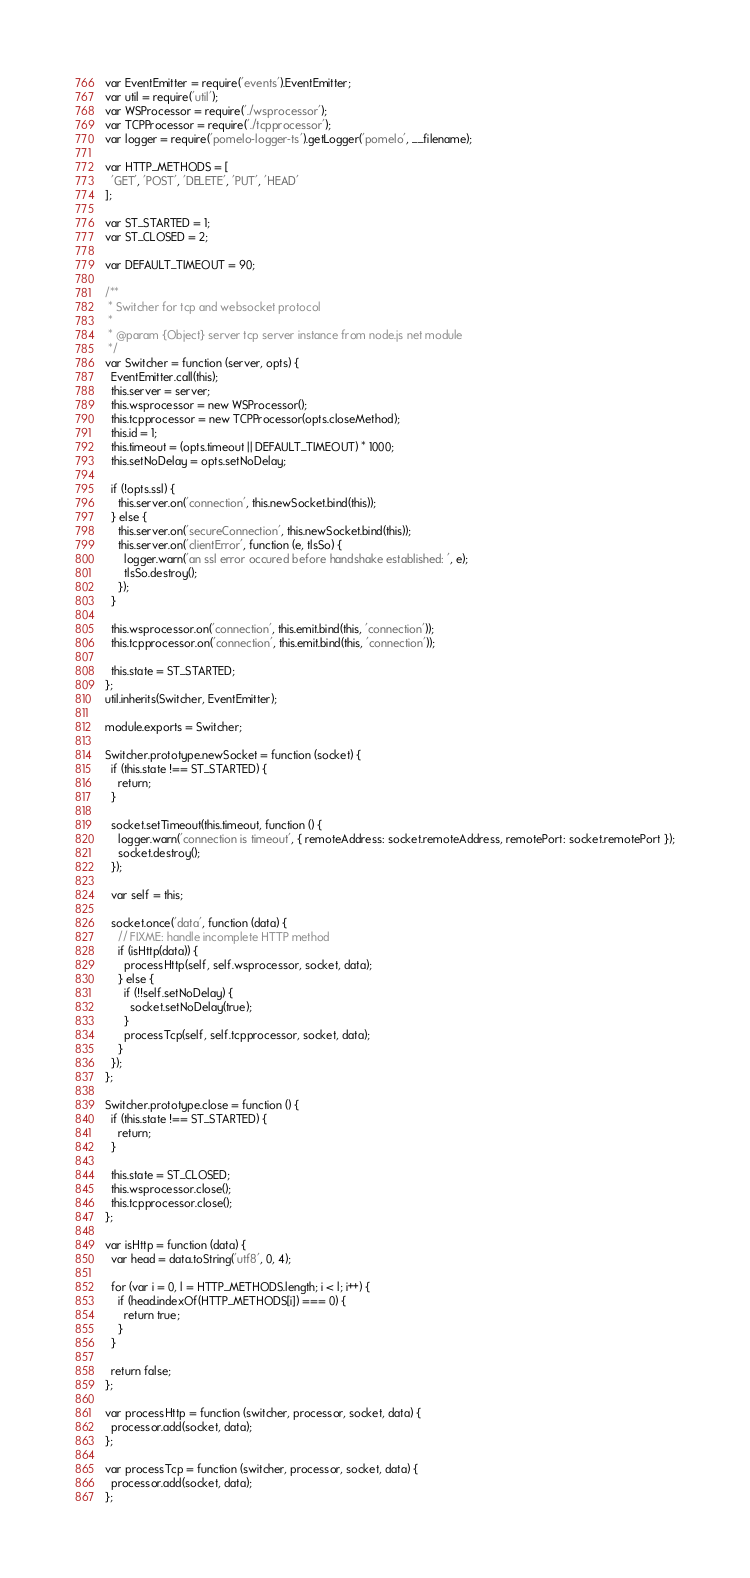<code> <loc_0><loc_0><loc_500><loc_500><_JavaScript_>var EventEmitter = require('events').EventEmitter;
var util = require('util');
var WSProcessor = require('./wsprocessor');
var TCPProcessor = require('./tcpprocessor');
var logger = require('pomelo-logger-ts').getLogger('pomelo', __filename);

var HTTP_METHODS = [
  'GET', 'POST', 'DELETE', 'PUT', 'HEAD'
];

var ST_STARTED = 1;
var ST_CLOSED = 2;

var DEFAULT_TIMEOUT = 90;

/**
 * Switcher for tcp and websocket protocol
 *
 * @param {Object} server tcp server instance from node.js net module
 */
var Switcher = function (server, opts) {
  EventEmitter.call(this);
  this.server = server;
  this.wsprocessor = new WSProcessor();
  this.tcpprocessor = new TCPProcessor(opts.closeMethod);
  this.id = 1;
  this.timeout = (opts.timeout || DEFAULT_TIMEOUT) * 1000;
  this.setNoDelay = opts.setNoDelay;

  if (!opts.ssl) {
    this.server.on('connection', this.newSocket.bind(this));
  } else {
    this.server.on('secureConnection', this.newSocket.bind(this));
    this.server.on('clientError', function (e, tlsSo) {
      logger.warn('an ssl error occured before handshake established: ', e);
      tlsSo.destroy();
    });
  }

  this.wsprocessor.on('connection', this.emit.bind(this, 'connection'));
  this.tcpprocessor.on('connection', this.emit.bind(this, 'connection'));

  this.state = ST_STARTED;
};
util.inherits(Switcher, EventEmitter);

module.exports = Switcher;

Switcher.prototype.newSocket = function (socket) {
  if (this.state !== ST_STARTED) {
    return;
  }

  socket.setTimeout(this.timeout, function () {
    logger.warn('connection is timeout', { remoteAddress: socket.remoteAddress, remotePort: socket.remotePort });
    socket.destroy();
  });

  var self = this;

  socket.once('data', function (data) {
    // FIXME: handle incomplete HTTP method
    if (isHttp(data)) {
      processHttp(self, self.wsprocessor, socket, data);
    } else {
      if (!!self.setNoDelay) {
        socket.setNoDelay(true);
      }
      processTcp(self, self.tcpprocessor, socket, data);
    }
  });
};

Switcher.prototype.close = function () {
  if (this.state !== ST_STARTED) {
    return;
  }

  this.state = ST_CLOSED;
  this.wsprocessor.close();
  this.tcpprocessor.close();
};

var isHttp = function (data) {
  var head = data.toString('utf8', 0, 4);

  for (var i = 0, l = HTTP_METHODS.length; i < l; i++) {
    if (head.indexOf(HTTP_METHODS[i]) === 0) {
      return true;
    }
  }

  return false;
};

var processHttp = function (switcher, processor, socket, data) {
  processor.add(socket, data);
};

var processTcp = function (switcher, processor, socket, data) {
  processor.add(socket, data);
};
</code> 